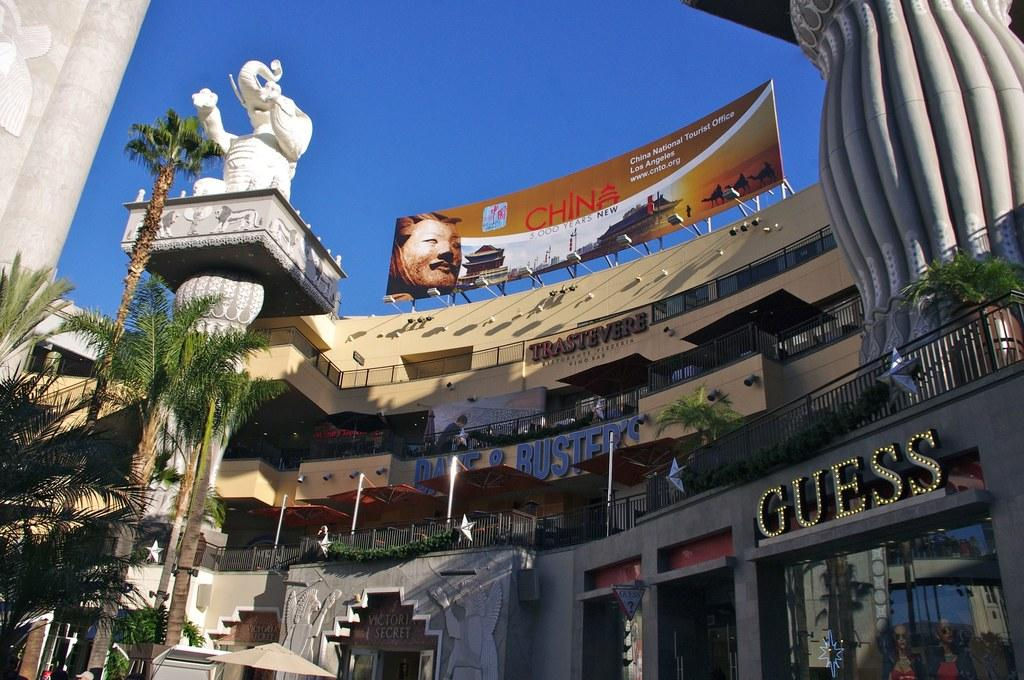What type of structures can be seen in the image? There are buildings in the image. Can you describe any specific features or objects in the image? Yes, there is a sculpture of an elephant in the left top of the image. What type of vegetation is present in the image? There are trees to the left in the image. What level of authority does the beginner have in the image? There is no reference to a beginner or any level of authority in the image. 